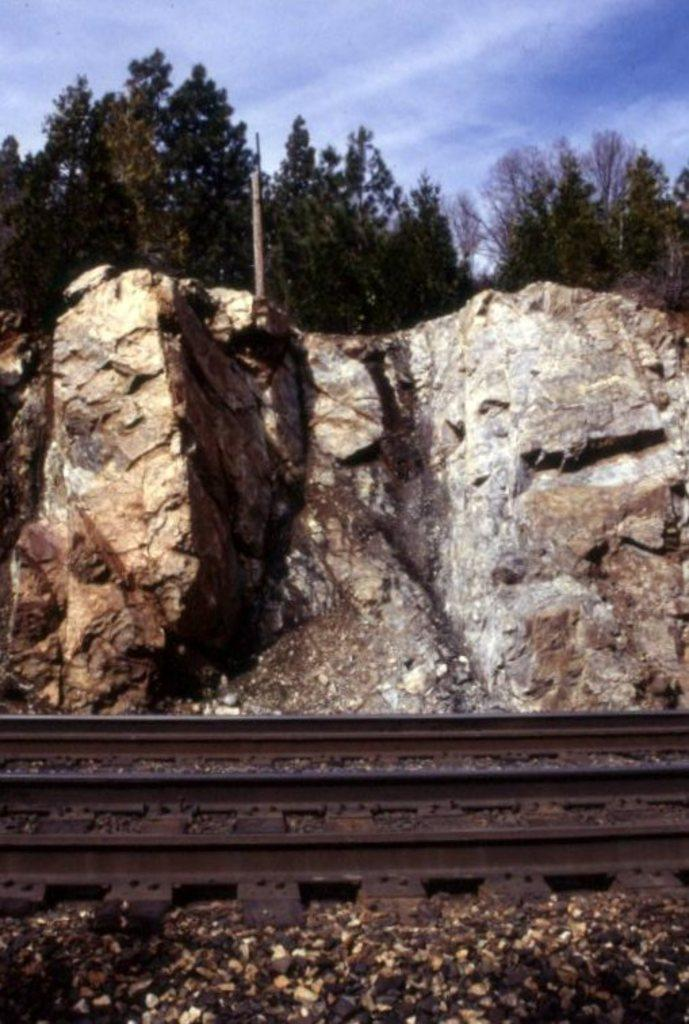What can be seen at the bottom of the image? There are tracks at the bottom side of the image. What is located in the center of the image? There are rocks in the center of the image. What type of vegetation is at the top of the image? There are trees at the top side of the image. Is there any blood visible on the rocks in the image? No, there is no blood visible in the image. What type of furniture can be seen in the middle of the image? There is no furniture present in the image; it features rocks, trees, and tracks. 